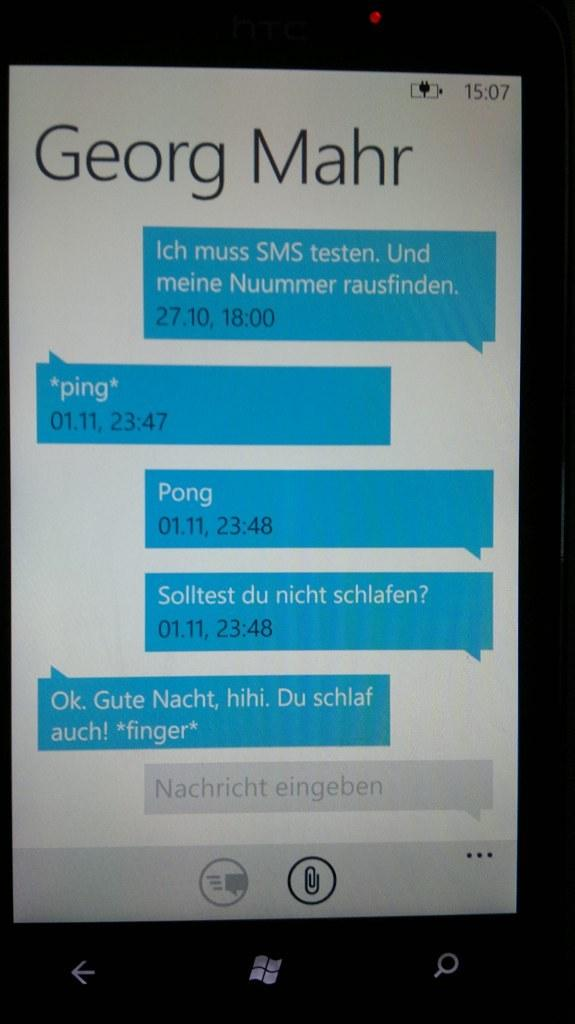Provide a one-sentence caption for the provided image. a screen shot of a conversation from Georg Mahr. 